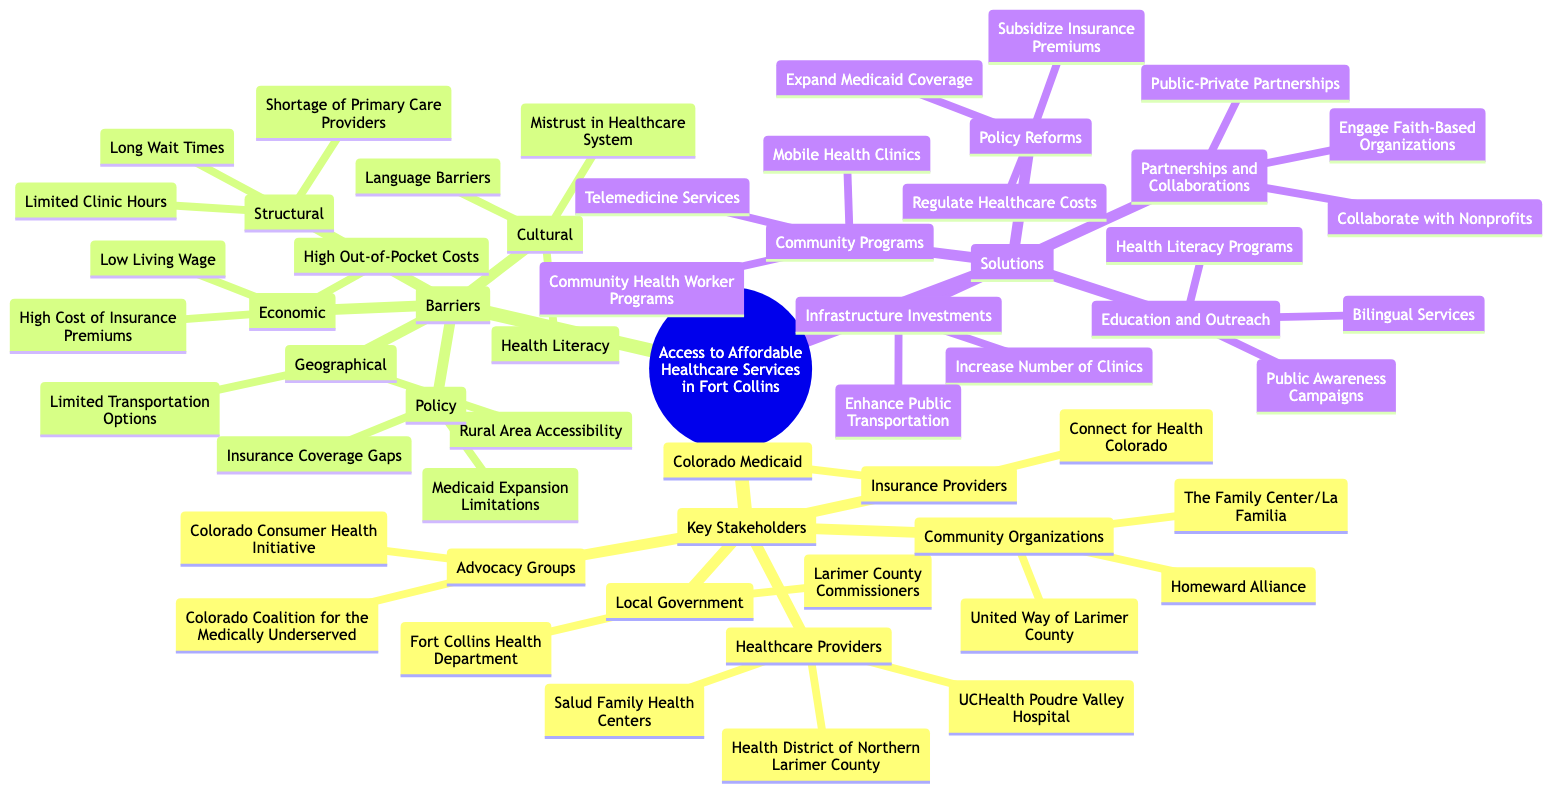What are the three main categories of Key Stakeholders? The diagram specifies that Key Stakeholders are categorized into Local Government, Healthcare Providers, Community Organizations, Insurance Providers, and Advocacy Groups. The three main categories that represent the largest stakeholder groups are Local Government, Healthcare Providers, and Community Organizations.
Answer: Local Government, Healthcare Providers, Community Organizations How many barriers are listed under the Economic category? The diagram indicates that there are three specific barriers listed under the Economic category: High Cost of Insurance Premiums, High Out-of-Pocket Costs, and Low Living Wage. Counting these gives a total of three barriers.
Answer: 3 Which advocacy group focuses on the medically underserved? The diagram identifies two advocacy groups within the Advocacy Groups category. The one specifically mentioned for focusing on the medically underserved is the Colorado Coalition for the Medically Underserved.
Answer: Colorado Coalition for the Medically Underserved What type of community program is mentioned for enhancing health service access? Among the solutions listed, there are several community programs mentioned. The one specifically aimed at enhancing access to healthcare is Mobile Health Clinics.
Answer: Mobile Health Clinics Which solution aims to address insurance premium costs? The diagram lists several solutions under Policy Reforms. The solution that specifically addresses insurance premium costs is Subsidize Insurance Premiums.
Answer: Subsidize Insurance Premiums How many types of barriers are identified in the diagram? The diagram classifies barriers into five distinct types: Economic, Geographical, Policy, Cultural, and Structural, that makes a total of five types of barriers.
Answer: 5 What Category includes the Fort Collins Health Department? The Fort Collins Health Department is identified under the Local Government category in the Key Stakeholders section of the diagram.
Answer: Local Government What is a proposed solution related to infrastructure? The solutions listed under Infrastructure Investments focus on enhancing healthcare services. One of the specific solutions proposed is Increasing Number of Clinics.
Answer: Increase Number of Clinics 